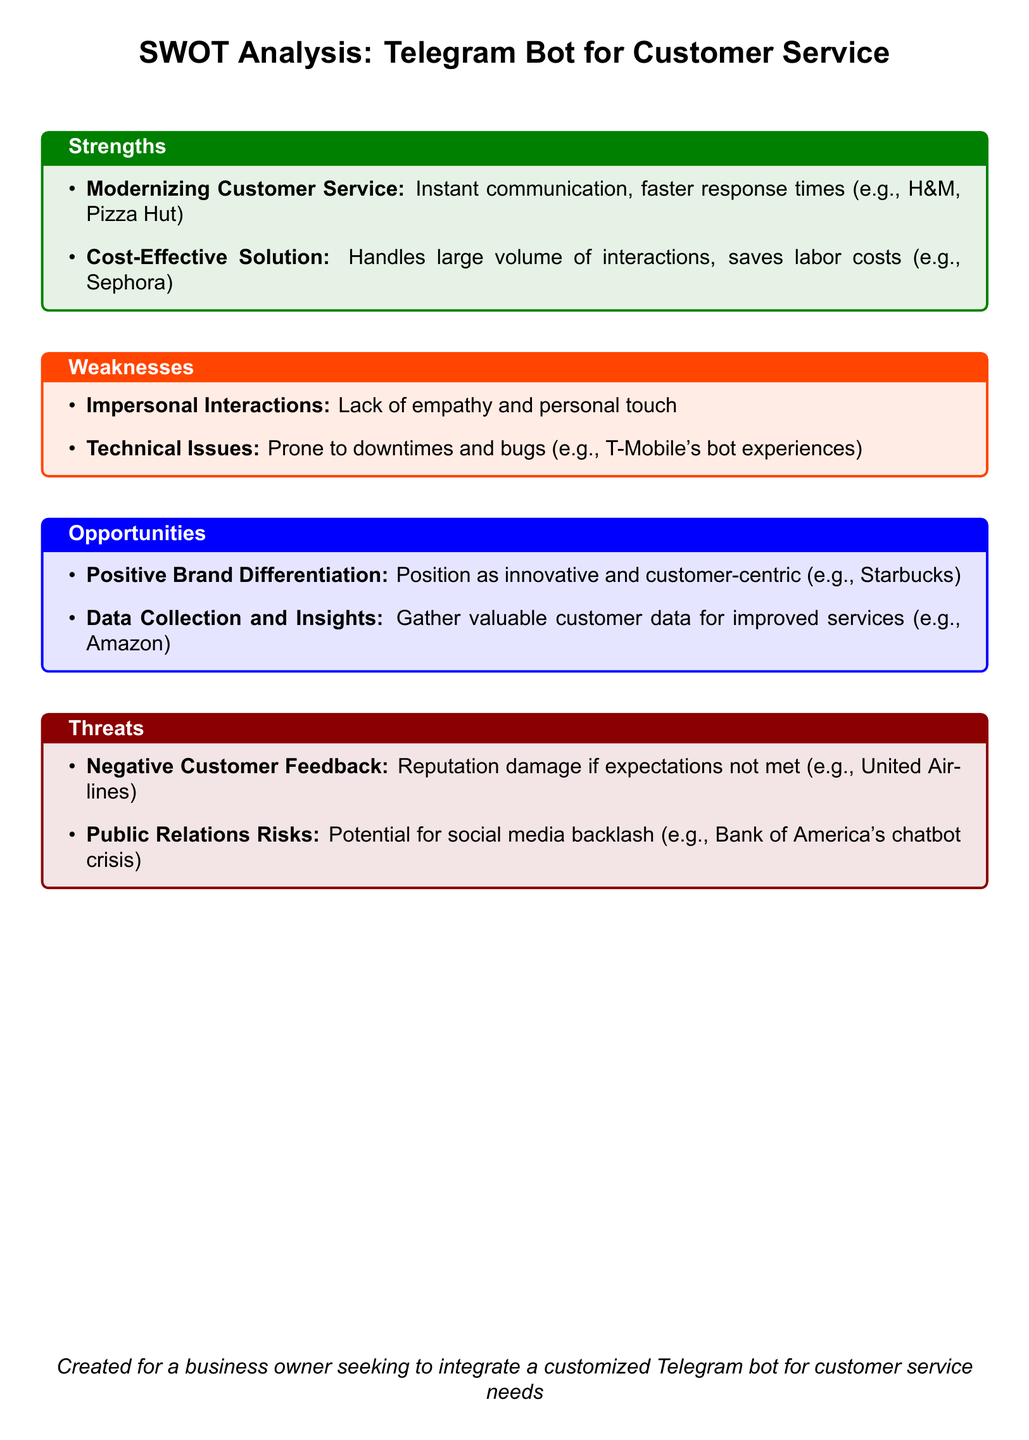What is one strength of using a Telegram bot? The document lists "Modernizing Customer Service" as a strength, highlighting instant communication and faster response times.
Answer: Modernizing Customer Service What is a potential weakness mentioned in the analysis? The document identifies "Impersonal Interactions" as a weakness, indicating a lack of empathy and personal touch in customer service.
Answer: Impersonal Interactions Which company example is provided for positive brand differentiation? The document cites Starbucks as a company that has positioned itself as innovative and customer-centric through a Telegram bot.
Answer: Starbucks What is one opportunity related to data mentioned? The document states that gathering valuable customer data for improved services is an opportunity that can be realized through the use of a Telegram bot.
Answer: Data Collection and Insights What is a threat associated with customer feedback? "Negative Customer Feedback" is listed as a threat that could damage a company's reputation if the bot does not meet customer expectations.
Answer: Negative Customer Feedback How many examples are given under the strengths section? There are two specific examples listed under the strengths section in the document.
Answer: Two What does the document note about technical issues? The document states that technical issues are a weakness, referring to them as prone to downtimes and bugs.
Answer: Prone to downtimes and bugs Which brand is noted for facing public relations risks related to chatbot use? According to the document, Bank of America faced a chatbot crisis that resulted in public relations risks.
Answer: Bank of America What overall impact does the document assess the Telegram bot may have on brand image? The document expresses that the Telegram bot could significantly influence brand perception positively but also carries inherent risks, thus assessing its overall impact.
Answer: Significant influence 